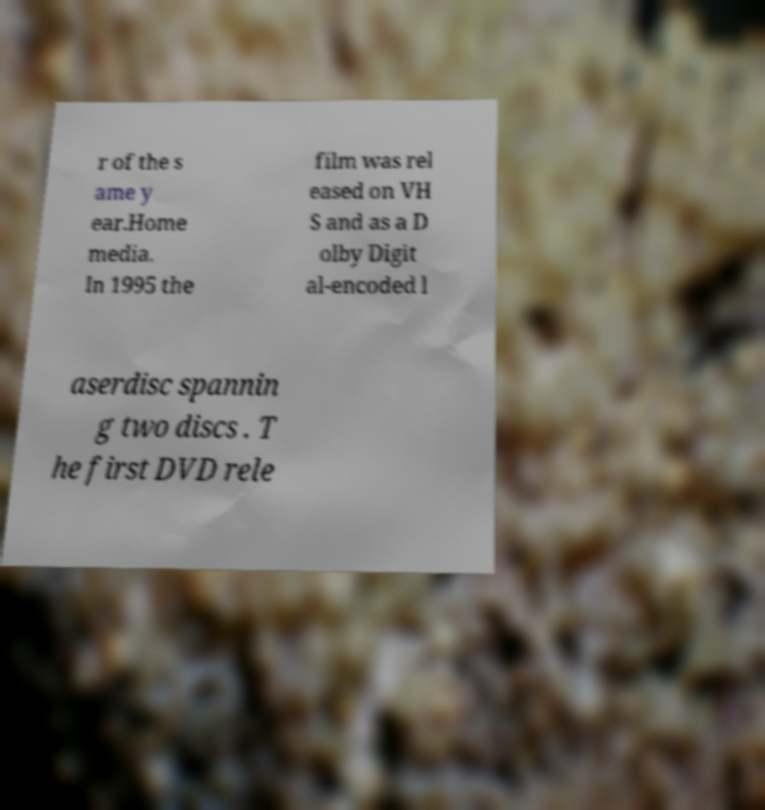There's text embedded in this image that I need extracted. Can you transcribe it verbatim? r of the s ame y ear.Home media. In 1995 the film was rel eased on VH S and as a D olby Digit al-encoded l aserdisc spannin g two discs . T he first DVD rele 